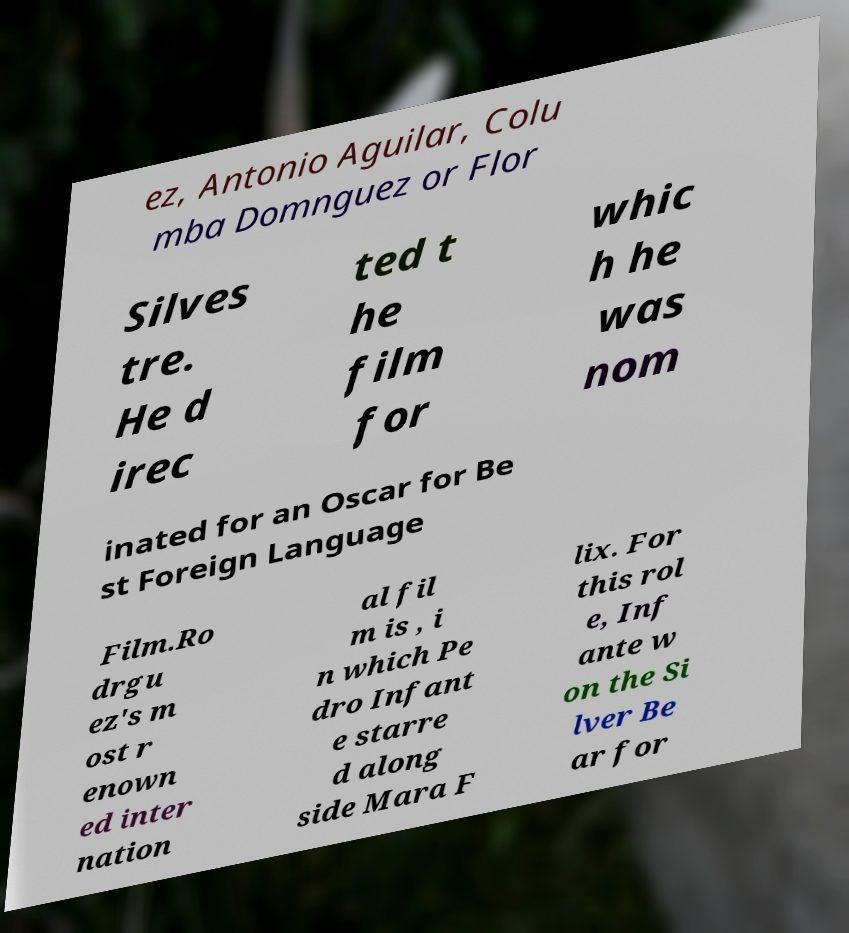Please identify and transcribe the text found in this image. ez, Antonio Aguilar, Colu mba Domnguez or Flor Silves tre. He d irec ted t he film for whic h he was nom inated for an Oscar for Be st Foreign Language Film.Ro drgu ez's m ost r enown ed inter nation al fil m is , i n which Pe dro Infant e starre d along side Mara F lix. For this rol e, Inf ante w on the Si lver Be ar for 